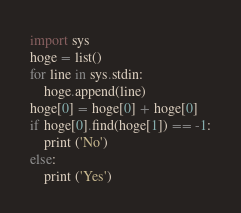<code> <loc_0><loc_0><loc_500><loc_500><_Python_>import sys
hoge = list()
for line in sys.stdin:
    hoge.append(line)
hoge[0] = hoge[0] + hoge[0]
if hoge[0].find(hoge[1]) == -1:
    print ('No')
else:
    print ('Yes')
</code> 